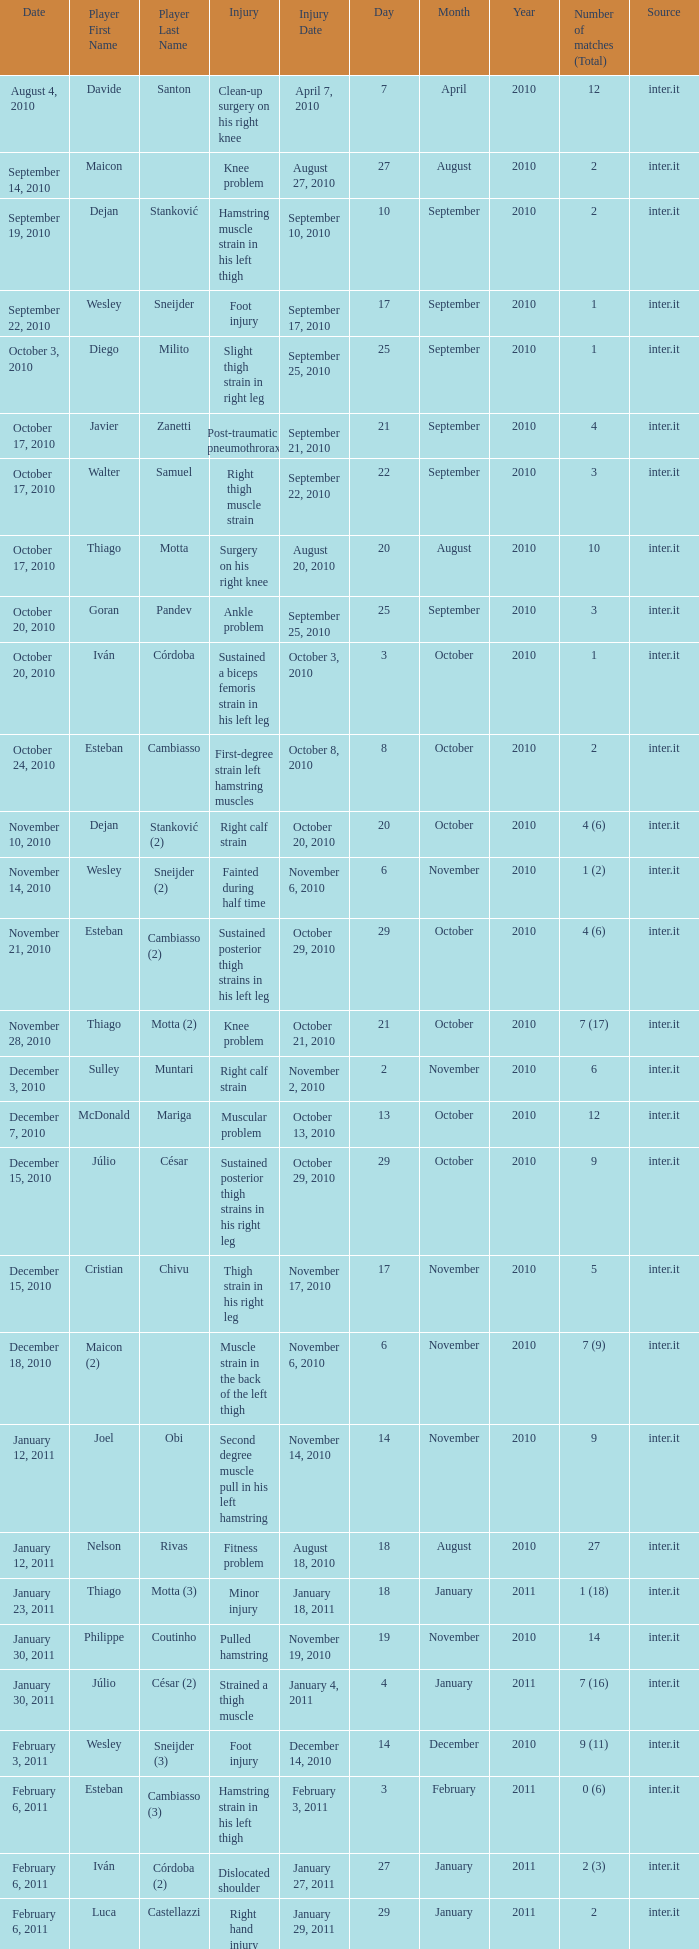When did player wesley sneijder (2) sustain the injury? November 6, 2010. 